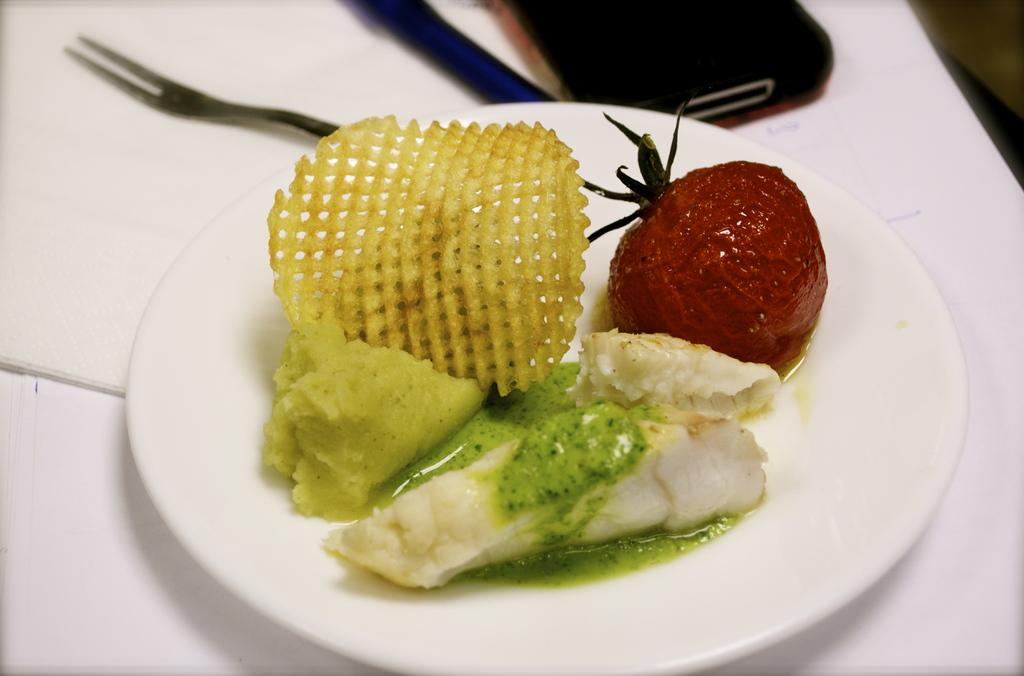What is on the plate in the image? There is a food item on a plate in the image. What utensil is present in the image? There is a fork in the image. What else can be seen on the table in the image? There are objects on the table in the image. What type of rhythm can be heard coming from the food item in the image? There is no rhythm associated with the food item in the image, as it is a static object. 